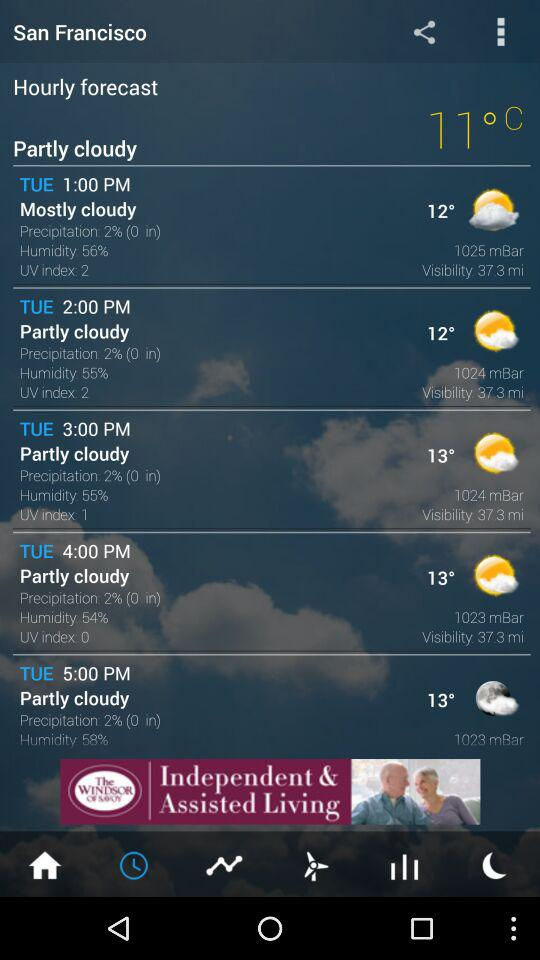What is the value of the UV index at 4:00 PM on Tuesday? The value of the UV index is 0. 